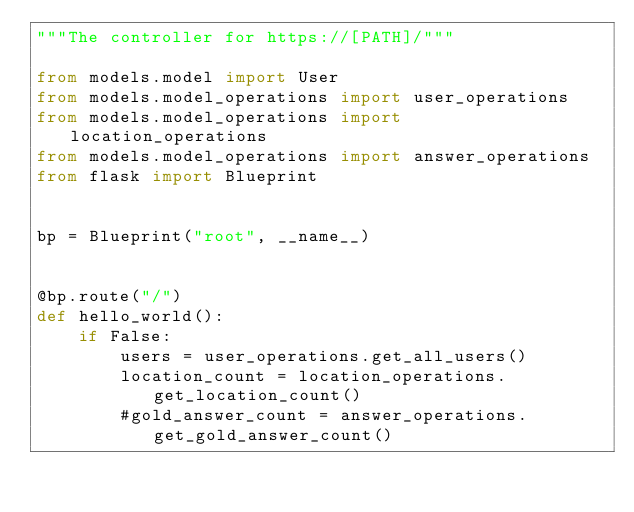Convert code to text. <code><loc_0><loc_0><loc_500><loc_500><_Python_>"""The controller for https://[PATH]/"""

from models.model import User
from models.model_operations import user_operations
from models.model_operations import location_operations
from models.model_operations import answer_operations
from flask import Blueprint


bp = Blueprint("root", __name__)


@bp.route("/")
def hello_world():
    if False:
        users = user_operations.get_all_users()
        location_count = location_operations.get_location_count()
        #gold_answer_count = answer_operations.get_gold_answer_count()
</code> 